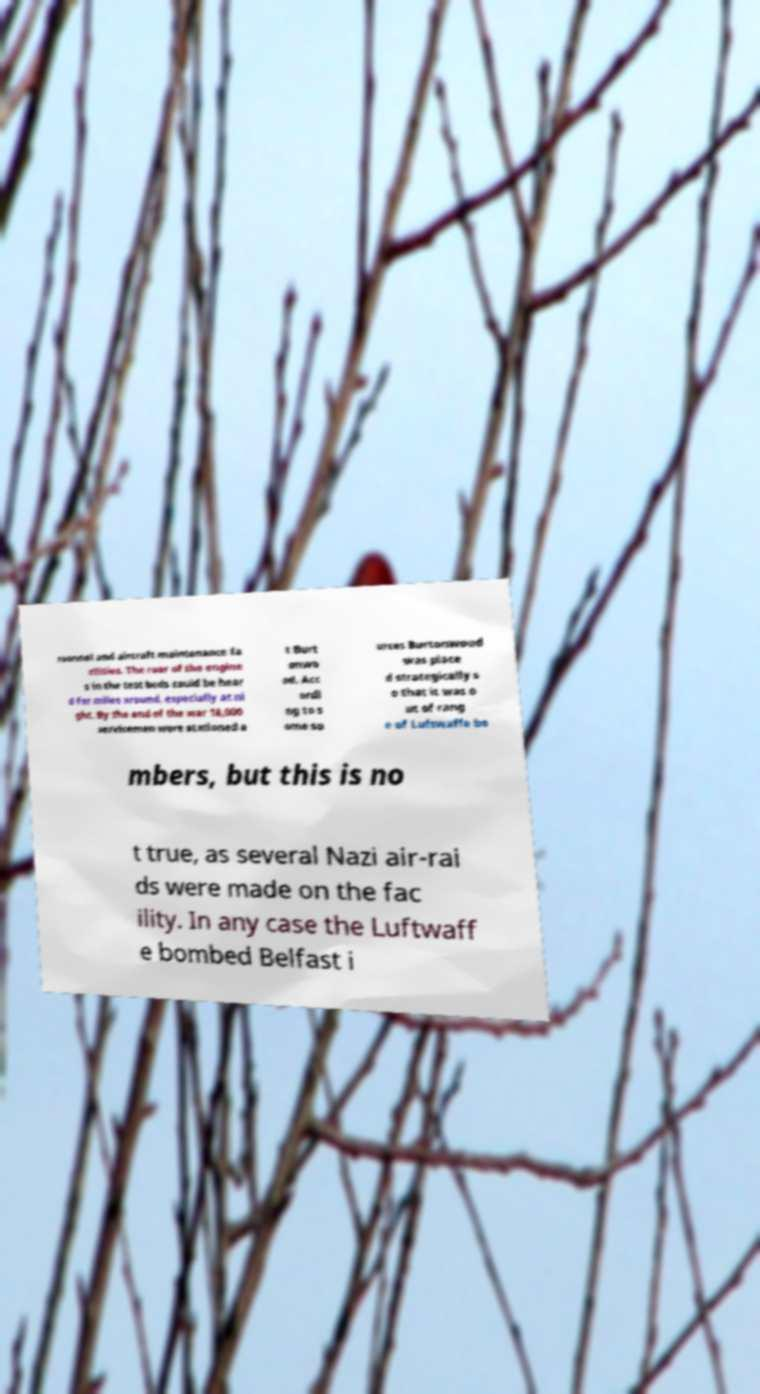Please read and relay the text visible in this image. What does it say? rsonnel and aircraft maintenance fa cilities. The roar of the engine s in the test beds could be hear d for miles around, especially at ni ght. By the end of the war 18,000 servicemen were stationed a t Burt onwo od. Acc ordi ng to s ome so urces Burtonwood was place d strategically s o that it was o ut of rang e of Luftwaffe bo mbers, but this is no t true, as several Nazi air-rai ds were made on the fac ility. In any case the Luftwaff e bombed Belfast i 